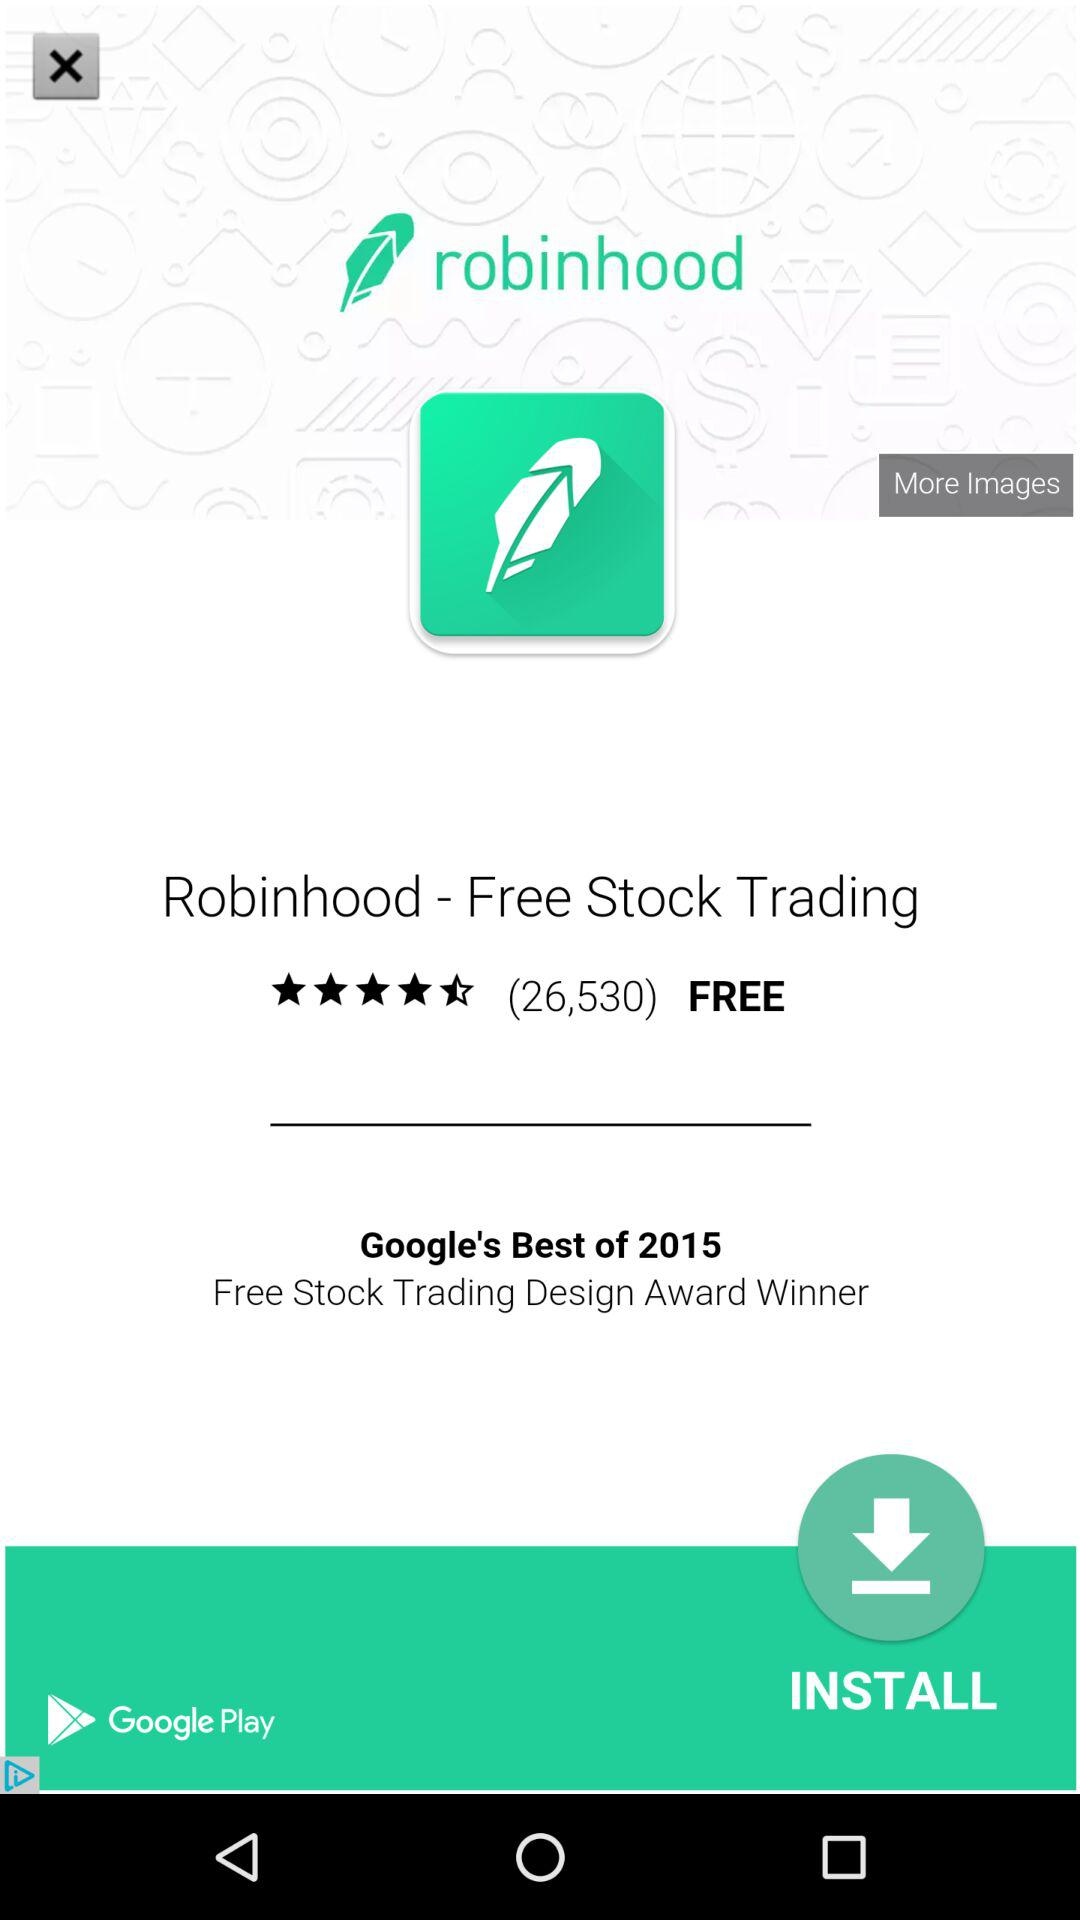What is the cost of the trading through the application? Trading through the application is free. 